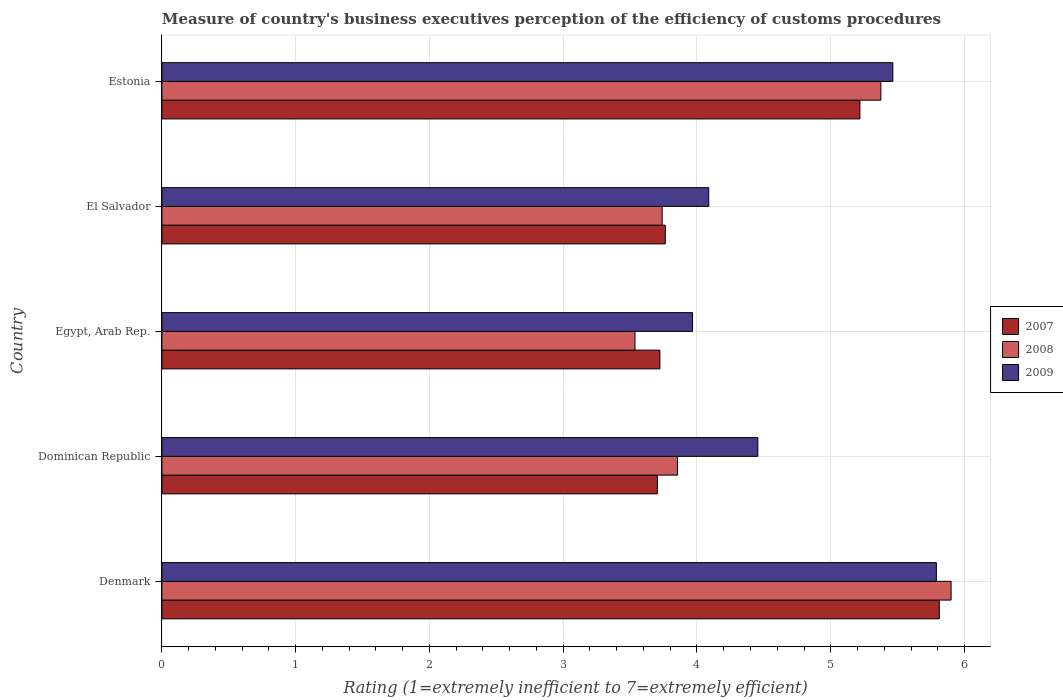How many different coloured bars are there?
Provide a short and direct response. 3. Are the number of bars per tick equal to the number of legend labels?
Provide a short and direct response. Yes. How many bars are there on the 2nd tick from the top?
Provide a succinct answer. 3. How many bars are there on the 5th tick from the bottom?
Offer a terse response. 3. What is the label of the 5th group of bars from the top?
Ensure brevity in your answer.  Denmark. In how many cases, is the number of bars for a given country not equal to the number of legend labels?
Provide a succinct answer. 0. What is the rating of the efficiency of customs procedure in 2009 in Denmark?
Ensure brevity in your answer.  5.79. Across all countries, what is the maximum rating of the efficiency of customs procedure in 2007?
Offer a terse response. 5.81. Across all countries, what is the minimum rating of the efficiency of customs procedure in 2008?
Provide a short and direct response. 3.54. In which country was the rating of the efficiency of customs procedure in 2007 minimum?
Make the answer very short. Dominican Republic. What is the total rating of the efficiency of customs procedure in 2007 in the graph?
Offer a terse response. 22.22. What is the difference between the rating of the efficiency of customs procedure in 2009 in Denmark and that in Dominican Republic?
Provide a succinct answer. 1.33. What is the difference between the rating of the efficiency of customs procedure in 2007 in Denmark and the rating of the efficiency of customs procedure in 2009 in Dominican Republic?
Make the answer very short. 1.36. What is the average rating of the efficiency of customs procedure in 2009 per country?
Your answer should be very brief. 4.75. What is the difference between the rating of the efficiency of customs procedure in 2007 and rating of the efficiency of customs procedure in 2009 in El Salvador?
Offer a terse response. -0.32. What is the ratio of the rating of the efficiency of customs procedure in 2008 in Egypt, Arab Rep. to that in Estonia?
Provide a short and direct response. 0.66. Is the rating of the efficiency of customs procedure in 2008 in Dominican Republic less than that in Egypt, Arab Rep.?
Your response must be concise. No. What is the difference between the highest and the second highest rating of the efficiency of customs procedure in 2008?
Your answer should be compact. 0.52. What is the difference between the highest and the lowest rating of the efficiency of customs procedure in 2009?
Offer a very short reply. 1.82. Is the sum of the rating of the efficiency of customs procedure in 2008 in Egypt, Arab Rep. and Estonia greater than the maximum rating of the efficiency of customs procedure in 2007 across all countries?
Your response must be concise. Yes. Is it the case that in every country, the sum of the rating of the efficiency of customs procedure in 2008 and rating of the efficiency of customs procedure in 2007 is greater than the rating of the efficiency of customs procedure in 2009?
Make the answer very short. Yes. How many bars are there?
Ensure brevity in your answer.  15. Are the values on the major ticks of X-axis written in scientific E-notation?
Make the answer very short. No. Does the graph contain any zero values?
Your answer should be compact. No. Where does the legend appear in the graph?
Your answer should be very brief. Center right. How many legend labels are there?
Provide a short and direct response. 3. What is the title of the graph?
Ensure brevity in your answer.  Measure of country's business executives perception of the efficiency of customs procedures. Does "1960" appear as one of the legend labels in the graph?
Provide a short and direct response. No. What is the label or title of the X-axis?
Keep it short and to the point. Rating (1=extremely inefficient to 7=extremely efficient). What is the Rating (1=extremely inefficient to 7=extremely efficient) in 2007 in Denmark?
Offer a very short reply. 5.81. What is the Rating (1=extremely inefficient to 7=extremely efficient) of 2008 in Denmark?
Provide a short and direct response. 5.9. What is the Rating (1=extremely inefficient to 7=extremely efficient) in 2009 in Denmark?
Offer a very short reply. 5.79. What is the Rating (1=extremely inefficient to 7=extremely efficient) in 2007 in Dominican Republic?
Ensure brevity in your answer.  3.7. What is the Rating (1=extremely inefficient to 7=extremely efficient) of 2008 in Dominican Republic?
Offer a terse response. 3.85. What is the Rating (1=extremely inefficient to 7=extremely efficient) in 2009 in Dominican Republic?
Provide a succinct answer. 4.46. What is the Rating (1=extremely inefficient to 7=extremely efficient) of 2007 in Egypt, Arab Rep.?
Your response must be concise. 3.72. What is the Rating (1=extremely inefficient to 7=extremely efficient) of 2008 in Egypt, Arab Rep.?
Your response must be concise. 3.54. What is the Rating (1=extremely inefficient to 7=extremely efficient) of 2009 in Egypt, Arab Rep.?
Your answer should be very brief. 3.97. What is the Rating (1=extremely inefficient to 7=extremely efficient) in 2007 in El Salvador?
Offer a very short reply. 3.76. What is the Rating (1=extremely inefficient to 7=extremely efficient) of 2008 in El Salvador?
Your answer should be compact. 3.74. What is the Rating (1=extremely inefficient to 7=extremely efficient) in 2009 in El Salvador?
Provide a short and direct response. 4.09. What is the Rating (1=extremely inefficient to 7=extremely efficient) in 2007 in Estonia?
Your answer should be compact. 5.22. What is the Rating (1=extremely inefficient to 7=extremely efficient) in 2008 in Estonia?
Your answer should be very brief. 5.37. What is the Rating (1=extremely inefficient to 7=extremely efficient) in 2009 in Estonia?
Keep it short and to the point. 5.46. Across all countries, what is the maximum Rating (1=extremely inefficient to 7=extremely efficient) of 2007?
Give a very brief answer. 5.81. Across all countries, what is the maximum Rating (1=extremely inefficient to 7=extremely efficient) of 2008?
Keep it short and to the point. 5.9. Across all countries, what is the maximum Rating (1=extremely inefficient to 7=extremely efficient) in 2009?
Give a very brief answer. 5.79. Across all countries, what is the minimum Rating (1=extremely inefficient to 7=extremely efficient) of 2007?
Give a very brief answer. 3.7. Across all countries, what is the minimum Rating (1=extremely inefficient to 7=extremely efficient) of 2008?
Ensure brevity in your answer.  3.54. Across all countries, what is the minimum Rating (1=extremely inefficient to 7=extremely efficient) in 2009?
Give a very brief answer. 3.97. What is the total Rating (1=extremely inefficient to 7=extremely efficient) in 2007 in the graph?
Provide a short and direct response. 22.22. What is the total Rating (1=extremely inefficient to 7=extremely efficient) of 2008 in the graph?
Provide a succinct answer. 22.4. What is the total Rating (1=extremely inefficient to 7=extremely efficient) of 2009 in the graph?
Make the answer very short. 23.76. What is the difference between the Rating (1=extremely inefficient to 7=extremely efficient) of 2007 in Denmark and that in Dominican Republic?
Ensure brevity in your answer.  2.11. What is the difference between the Rating (1=extremely inefficient to 7=extremely efficient) of 2008 in Denmark and that in Dominican Republic?
Offer a terse response. 2.05. What is the difference between the Rating (1=extremely inefficient to 7=extremely efficient) in 2009 in Denmark and that in Dominican Republic?
Give a very brief answer. 1.33. What is the difference between the Rating (1=extremely inefficient to 7=extremely efficient) of 2007 in Denmark and that in Egypt, Arab Rep.?
Provide a short and direct response. 2.09. What is the difference between the Rating (1=extremely inefficient to 7=extremely efficient) of 2008 in Denmark and that in Egypt, Arab Rep.?
Keep it short and to the point. 2.36. What is the difference between the Rating (1=extremely inefficient to 7=extremely efficient) of 2009 in Denmark and that in Egypt, Arab Rep.?
Provide a succinct answer. 1.82. What is the difference between the Rating (1=extremely inefficient to 7=extremely efficient) in 2007 in Denmark and that in El Salvador?
Provide a short and direct response. 2.05. What is the difference between the Rating (1=extremely inefficient to 7=extremely efficient) in 2008 in Denmark and that in El Salvador?
Your answer should be compact. 2.16. What is the difference between the Rating (1=extremely inefficient to 7=extremely efficient) in 2009 in Denmark and that in El Salvador?
Keep it short and to the point. 1.7. What is the difference between the Rating (1=extremely inefficient to 7=extremely efficient) of 2007 in Denmark and that in Estonia?
Provide a short and direct response. 0.59. What is the difference between the Rating (1=extremely inefficient to 7=extremely efficient) in 2008 in Denmark and that in Estonia?
Ensure brevity in your answer.  0.53. What is the difference between the Rating (1=extremely inefficient to 7=extremely efficient) of 2009 in Denmark and that in Estonia?
Your answer should be very brief. 0.33. What is the difference between the Rating (1=extremely inefficient to 7=extremely efficient) in 2007 in Dominican Republic and that in Egypt, Arab Rep.?
Give a very brief answer. -0.02. What is the difference between the Rating (1=extremely inefficient to 7=extremely efficient) in 2008 in Dominican Republic and that in Egypt, Arab Rep.?
Offer a terse response. 0.32. What is the difference between the Rating (1=extremely inefficient to 7=extremely efficient) of 2009 in Dominican Republic and that in Egypt, Arab Rep.?
Give a very brief answer. 0.49. What is the difference between the Rating (1=extremely inefficient to 7=extremely efficient) of 2007 in Dominican Republic and that in El Salvador?
Give a very brief answer. -0.06. What is the difference between the Rating (1=extremely inefficient to 7=extremely efficient) of 2008 in Dominican Republic and that in El Salvador?
Make the answer very short. 0.11. What is the difference between the Rating (1=extremely inefficient to 7=extremely efficient) of 2009 in Dominican Republic and that in El Salvador?
Offer a terse response. 0.37. What is the difference between the Rating (1=extremely inefficient to 7=extremely efficient) of 2007 in Dominican Republic and that in Estonia?
Offer a terse response. -1.51. What is the difference between the Rating (1=extremely inefficient to 7=extremely efficient) of 2008 in Dominican Republic and that in Estonia?
Offer a terse response. -1.52. What is the difference between the Rating (1=extremely inefficient to 7=extremely efficient) of 2009 in Dominican Republic and that in Estonia?
Give a very brief answer. -1.01. What is the difference between the Rating (1=extremely inefficient to 7=extremely efficient) of 2007 in Egypt, Arab Rep. and that in El Salvador?
Offer a very short reply. -0.04. What is the difference between the Rating (1=extremely inefficient to 7=extremely efficient) in 2008 in Egypt, Arab Rep. and that in El Salvador?
Provide a succinct answer. -0.2. What is the difference between the Rating (1=extremely inefficient to 7=extremely efficient) in 2009 in Egypt, Arab Rep. and that in El Salvador?
Give a very brief answer. -0.12. What is the difference between the Rating (1=extremely inefficient to 7=extremely efficient) of 2007 in Egypt, Arab Rep. and that in Estonia?
Provide a short and direct response. -1.5. What is the difference between the Rating (1=extremely inefficient to 7=extremely efficient) in 2008 in Egypt, Arab Rep. and that in Estonia?
Keep it short and to the point. -1.84. What is the difference between the Rating (1=extremely inefficient to 7=extremely efficient) in 2009 in Egypt, Arab Rep. and that in Estonia?
Give a very brief answer. -1.5. What is the difference between the Rating (1=extremely inefficient to 7=extremely efficient) in 2007 in El Salvador and that in Estonia?
Make the answer very short. -1.45. What is the difference between the Rating (1=extremely inefficient to 7=extremely efficient) of 2008 in El Salvador and that in Estonia?
Your answer should be very brief. -1.63. What is the difference between the Rating (1=extremely inefficient to 7=extremely efficient) in 2009 in El Salvador and that in Estonia?
Provide a succinct answer. -1.38. What is the difference between the Rating (1=extremely inefficient to 7=extremely efficient) of 2007 in Denmark and the Rating (1=extremely inefficient to 7=extremely efficient) of 2008 in Dominican Republic?
Provide a succinct answer. 1.96. What is the difference between the Rating (1=extremely inefficient to 7=extremely efficient) of 2007 in Denmark and the Rating (1=extremely inefficient to 7=extremely efficient) of 2009 in Dominican Republic?
Make the answer very short. 1.36. What is the difference between the Rating (1=extremely inefficient to 7=extremely efficient) of 2008 in Denmark and the Rating (1=extremely inefficient to 7=extremely efficient) of 2009 in Dominican Republic?
Provide a short and direct response. 1.44. What is the difference between the Rating (1=extremely inefficient to 7=extremely efficient) in 2007 in Denmark and the Rating (1=extremely inefficient to 7=extremely efficient) in 2008 in Egypt, Arab Rep.?
Your answer should be very brief. 2.28. What is the difference between the Rating (1=extremely inefficient to 7=extremely efficient) in 2007 in Denmark and the Rating (1=extremely inefficient to 7=extremely efficient) in 2009 in Egypt, Arab Rep.?
Provide a short and direct response. 1.84. What is the difference between the Rating (1=extremely inefficient to 7=extremely efficient) of 2008 in Denmark and the Rating (1=extremely inefficient to 7=extremely efficient) of 2009 in Egypt, Arab Rep.?
Your answer should be compact. 1.93. What is the difference between the Rating (1=extremely inefficient to 7=extremely efficient) in 2007 in Denmark and the Rating (1=extremely inefficient to 7=extremely efficient) in 2008 in El Salvador?
Make the answer very short. 2.07. What is the difference between the Rating (1=extremely inefficient to 7=extremely efficient) of 2007 in Denmark and the Rating (1=extremely inefficient to 7=extremely efficient) of 2009 in El Salvador?
Give a very brief answer. 1.72. What is the difference between the Rating (1=extremely inefficient to 7=extremely efficient) in 2008 in Denmark and the Rating (1=extremely inefficient to 7=extremely efficient) in 2009 in El Salvador?
Your answer should be compact. 1.81. What is the difference between the Rating (1=extremely inefficient to 7=extremely efficient) in 2007 in Denmark and the Rating (1=extremely inefficient to 7=extremely efficient) in 2008 in Estonia?
Your answer should be compact. 0.44. What is the difference between the Rating (1=extremely inefficient to 7=extremely efficient) in 2007 in Denmark and the Rating (1=extremely inefficient to 7=extremely efficient) in 2009 in Estonia?
Keep it short and to the point. 0.35. What is the difference between the Rating (1=extremely inefficient to 7=extremely efficient) of 2008 in Denmark and the Rating (1=extremely inefficient to 7=extremely efficient) of 2009 in Estonia?
Ensure brevity in your answer.  0.44. What is the difference between the Rating (1=extremely inefficient to 7=extremely efficient) in 2007 in Dominican Republic and the Rating (1=extremely inefficient to 7=extremely efficient) in 2008 in Egypt, Arab Rep.?
Make the answer very short. 0.17. What is the difference between the Rating (1=extremely inefficient to 7=extremely efficient) of 2007 in Dominican Republic and the Rating (1=extremely inefficient to 7=extremely efficient) of 2009 in Egypt, Arab Rep.?
Your answer should be very brief. -0.26. What is the difference between the Rating (1=extremely inefficient to 7=extremely efficient) of 2008 in Dominican Republic and the Rating (1=extremely inefficient to 7=extremely efficient) of 2009 in Egypt, Arab Rep.?
Give a very brief answer. -0.11. What is the difference between the Rating (1=extremely inefficient to 7=extremely efficient) of 2007 in Dominican Republic and the Rating (1=extremely inefficient to 7=extremely efficient) of 2008 in El Salvador?
Give a very brief answer. -0.04. What is the difference between the Rating (1=extremely inefficient to 7=extremely efficient) of 2007 in Dominican Republic and the Rating (1=extremely inefficient to 7=extremely efficient) of 2009 in El Salvador?
Make the answer very short. -0.38. What is the difference between the Rating (1=extremely inefficient to 7=extremely efficient) of 2008 in Dominican Republic and the Rating (1=extremely inefficient to 7=extremely efficient) of 2009 in El Salvador?
Provide a short and direct response. -0.23. What is the difference between the Rating (1=extremely inefficient to 7=extremely efficient) in 2007 in Dominican Republic and the Rating (1=extremely inefficient to 7=extremely efficient) in 2008 in Estonia?
Offer a terse response. -1.67. What is the difference between the Rating (1=extremely inefficient to 7=extremely efficient) of 2007 in Dominican Republic and the Rating (1=extremely inefficient to 7=extremely efficient) of 2009 in Estonia?
Give a very brief answer. -1.76. What is the difference between the Rating (1=extremely inefficient to 7=extremely efficient) of 2008 in Dominican Republic and the Rating (1=extremely inefficient to 7=extremely efficient) of 2009 in Estonia?
Provide a succinct answer. -1.61. What is the difference between the Rating (1=extremely inefficient to 7=extremely efficient) of 2007 in Egypt, Arab Rep. and the Rating (1=extremely inefficient to 7=extremely efficient) of 2008 in El Salvador?
Provide a short and direct response. -0.02. What is the difference between the Rating (1=extremely inefficient to 7=extremely efficient) of 2007 in Egypt, Arab Rep. and the Rating (1=extremely inefficient to 7=extremely efficient) of 2009 in El Salvador?
Make the answer very short. -0.36. What is the difference between the Rating (1=extremely inefficient to 7=extremely efficient) of 2008 in Egypt, Arab Rep. and the Rating (1=extremely inefficient to 7=extremely efficient) of 2009 in El Salvador?
Provide a short and direct response. -0.55. What is the difference between the Rating (1=extremely inefficient to 7=extremely efficient) of 2007 in Egypt, Arab Rep. and the Rating (1=extremely inefficient to 7=extremely efficient) of 2008 in Estonia?
Make the answer very short. -1.65. What is the difference between the Rating (1=extremely inefficient to 7=extremely efficient) of 2007 in Egypt, Arab Rep. and the Rating (1=extremely inefficient to 7=extremely efficient) of 2009 in Estonia?
Your response must be concise. -1.74. What is the difference between the Rating (1=extremely inefficient to 7=extremely efficient) in 2008 in Egypt, Arab Rep. and the Rating (1=extremely inefficient to 7=extremely efficient) in 2009 in Estonia?
Your response must be concise. -1.93. What is the difference between the Rating (1=extremely inefficient to 7=extremely efficient) in 2007 in El Salvador and the Rating (1=extremely inefficient to 7=extremely efficient) in 2008 in Estonia?
Your answer should be compact. -1.61. What is the difference between the Rating (1=extremely inefficient to 7=extremely efficient) in 2007 in El Salvador and the Rating (1=extremely inefficient to 7=extremely efficient) in 2009 in Estonia?
Provide a short and direct response. -1.7. What is the difference between the Rating (1=extremely inefficient to 7=extremely efficient) of 2008 in El Salvador and the Rating (1=extremely inefficient to 7=extremely efficient) of 2009 in Estonia?
Give a very brief answer. -1.72. What is the average Rating (1=extremely inefficient to 7=extremely efficient) in 2007 per country?
Make the answer very short. 4.44. What is the average Rating (1=extremely inefficient to 7=extremely efficient) of 2008 per country?
Keep it short and to the point. 4.48. What is the average Rating (1=extremely inefficient to 7=extremely efficient) of 2009 per country?
Offer a terse response. 4.75. What is the difference between the Rating (1=extremely inefficient to 7=extremely efficient) in 2007 and Rating (1=extremely inefficient to 7=extremely efficient) in 2008 in Denmark?
Make the answer very short. -0.09. What is the difference between the Rating (1=extremely inefficient to 7=extremely efficient) of 2007 and Rating (1=extremely inefficient to 7=extremely efficient) of 2009 in Denmark?
Make the answer very short. 0.02. What is the difference between the Rating (1=extremely inefficient to 7=extremely efficient) in 2008 and Rating (1=extremely inefficient to 7=extremely efficient) in 2009 in Denmark?
Make the answer very short. 0.11. What is the difference between the Rating (1=extremely inefficient to 7=extremely efficient) of 2007 and Rating (1=extremely inefficient to 7=extremely efficient) of 2008 in Dominican Republic?
Your answer should be compact. -0.15. What is the difference between the Rating (1=extremely inefficient to 7=extremely efficient) in 2007 and Rating (1=extremely inefficient to 7=extremely efficient) in 2009 in Dominican Republic?
Make the answer very short. -0.75. What is the difference between the Rating (1=extremely inefficient to 7=extremely efficient) of 2008 and Rating (1=extremely inefficient to 7=extremely efficient) of 2009 in Dominican Republic?
Give a very brief answer. -0.6. What is the difference between the Rating (1=extremely inefficient to 7=extremely efficient) of 2007 and Rating (1=extremely inefficient to 7=extremely efficient) of 2008 in Egypt, Arab Rep.?
Keep it short and to the point. 0.19. What is the difference between the Rating (1=extremely inefficient to 7=extremely efficient) of 2007 and Rating (1=extremely inefficient to 7=extremely efficient) of 2009 in Egypt, Arab Rep.?
Offer a very short reply. -0.24. What is the difference between the Rating (1=extremely inefficient to 7=extremely efficient) in 2008 and Rating (1=extremely inefficient to 7=extremely efficient) in 2009 in Egypt, Arab Rep.?
Make the answer very short. -0.43. What is the difference between the Rating (1=extremely inefficient to 7=extremely efficient) of 2007 and Rating (1=extremely inefficient to 7=extremely efficient) of 2008 in El Salvador?
Offer a terse response. 0.02. What is the difference between the Rating (1=extremely inefficient to 7=extremely efficient) in 2007 and Rating (1=extremely inefficient to 7=extremely efficient) in 2009 in El Salvador?
Your answer should be compact. -0.32. What is the difference between the Rating (1=extremely inefficient to 7=extremely efficient) of 2008 and Rating (1=extremely inefficient to 7=extremely efficient) of 2009 in El Salvador?
Provide a succinct answer. -0.35. What is the difference between the Rating (1=extremely inefficient to 7=extremely efficient) in 2007 and Rating (1=extremely inefficient to 7=extremely efficient) in 2008 in Estonia?
Provide a short and direct response. -0.16. What is the difference between the Rating (1=extremely inefficient to 7=extremely efficient) of 2007 and Rating (1=extremely inefficient to 7=extremely efficient) of 2009 in Estonia?
Ensure brevity in your answer.  -0.25. What is the difference between the Rating (1=extremely inefficient to 7=extremely efficient) of 2008 and Rating (1=extremely inefficient to 7=extremely efficient) of 2009 in Estonia?
Your response must be concise. -0.09. What is the ratio of the Rating (1=extremely inefficient to 7=extremely efficient) in 2007 in Denmark to that in Dominican Republic?
Offer a terse response. 1.57. What is the ratio of the Rating (1=extremely inefficient to 7=extremely efficient) in 2008 in Denmark to that in Dominican Republic?
Your answer should be very brief. 1.53. What is the ratio of the Rating (1=extremely inefficient to 7=extremely efficient) in 2009 in Denmark to that in Dominican Republic?
Provide a short and direct response. 1.3. What is the ratio of the Rating (1=extremely inefficient to 7=extremely efficient) of 2007 in Denmark to that in Egypt, Arab Rep.?
Offer a very short reply. 1.56. What is the ratio of the Rating (1=extremely inefficient to 7=extremely efficient) of 2008 in Denmark to that in Egypt, Arab Rep.?
Your response must be concise. 1.67. What is the ratio of the Rating (1=extremely inefficient to 7=extremely efficient) in 2009 in Denmark to that in Egypt, Arab Rep.?
Give a very brief answer. 1.46. What is the ratio of the Rating (1=extremely inefficient to 7=extremely efficient) in 2007 in Denmark to that in El Salvador?
Your answer should be compact. 1.54. What is the ratio of the Rating (1=extremely inefficient to 7=extremely efficient) in 2008 in Denmark to that in El Salvador?
Give a very brief answer. 1.58. What is the ratio of the Rating (1=extremely inefficient to 7=extremely efficient) of 2009 in Denmark to that in El Salvador?
Your answer should be compact. 1.42. What is the ratio of the Rating (1=extremely inefficient to 7=extremely efficient) of 2007 in Denmark to that in Estonia?
Give a very brief answer. 1.11. What is the ratio of the Rating (1=extremely inefficient to 7=extremely efficient) in 2008 in Denmark to that in Estonia?
Ensure brevity in your answer.  1.1. What is the ratio of the Rating (1=extremely inefficient to 7=extremely efficient) of 2009 in Denmark to that in Estonia?
Offer a very short reply. 1.06. What is the ratio of the Rating (1=extremely inefficient to 7=extremely efficient) in 2007 in Dominican Republic to that in Egypt, Arab Rep.?
Ensure brevity in your answer.  0.99. What is the ratio of the Rating (1=extremely inefficient to 7=extremely efficient) of 2008 in Dominican Republic to that in Egypt, Arab Rep.?
Offer a very short reply. 1.09. What is the ratio of the Rating (1=extremely inefficient to 7=extremely efficient) in 2009 in Dominican Republic to that in Egypt, Arab Rep.?
Keep it short and to the point. 1.12. What is the ratio of the Rating (1=extremely inefficient to 7=extremely efficient) of 2007 in Dominican Republic to that in El Salvador?
Offer a terse response. 0.98. What is the ratio of the Rating (1=extremely inefficient to 7=extremely efficient) in 2008 in Dominican Republic to that in El Salvador?
Make the answer very short. 1.03. What is the ratio of the Rating (1=extremely inefficient to 7=extremely efficient) of 2009 in Dominican Republic to that in El Salvador?
Offer a very short reply. 1.09. What is the ratio of the Rating (1=extremely inefficient to 7=extremely efficient) in 2007 in Dominican Republic to that in Estonia?
Your answer should be very brief. 0.71. What is the ratio of the Rating (1=extremely inefficient to 7=extremely efficient) of 2008 in Dominican Republic to that in Estonia?
Make the answer very short. 0.72. What is the ratio of the Rating (1=extremely inefficient to 7=extremely efficient) in 2009 in Dominican Republic to that in Estonia?
Give a very brief answer. 0.82. What is the ratio of the Rating (1=extremely inefficient to 7=extremely efficient) in 2007 in Egypt, Arab Rep. to that in El Salvador?
Make the answer very short. 0.99. What is the ratio of the Rating (1=extremely inefficient to 7=extremely efficient) of 2008 in Egypt, Arab Rep. to that in El Salvador?
Ensure brevity in your answer.  0.95. What is the ratio of the Rating (1=extremely inefficient to 7=extremely efficient) in 2009 in Egypt, Arab Rep. to that in El Salvador?
Your answer should be compact. 0.97. What is the ratio of the Rating (1=extremely inefficient to 7=extremely efficient) of 2007 in Egypt, Arab Rep. to that in Estonia?
Your response must be concise. 0.71. What is the ratio of the Rating (1=extremely inefficient to 7=extremely efficient) in 2008 in Egypt, Arab Rep. to that in Estonia?
Your answer should be compact. 0.66. What is the ratio of the Rating (1=extremely inefficient to 7=extremely efficient) of 2009 in Egypt, Arab Rep. to that in Estonia?
Ensure brevity in your answer.  0.73. What is the ratio of the Rating (1=extremely inefficient to 7=extremely efficient) of 2007 in El Salvador to that in Estonia?
Keep it short and to the point. 0.72. What is the ratio of the Rating (1=extremely inefficient to 7=extremely efficient) of 2008 in El Salvador to that in Estonia?
Keep it short and to the point. 0.7. What is the ratio of the Rating (1=extremely inefficient to 7=extremely efficient) of 2009 in El Salvador to that in Estonia?
Your response must be concise. 0.75. What is the difference between the highest and the second highest Rating (1=extremely inefficient to 7=extremely efficient) in 2007?
Make the answer very short. 0.59. What is the difference between the highest and the second highest Rating (1=extremely inefficient to 7=extremely efficient) in 2008?
Your answer should be very brief. 0.53. What is the difference between the highest and the second highest Rating (1=extremely inefficient to 7=extremely efficient) in 2009?
Your response must be concise. 0.33. What is the difference between the highest and the lowest Rating (1=extremely inefficient to 7=extremely efficient) in 2007?
Make the answer very short. 2.11. What is the difference between the highest and the lowest Rating (1=extremely inefficient to 7=extremely efficient) of 2008?
Provide a succinct answer. 2.36. What is the difference between the highest and the lowest Rating (1=extremely inefficient to 7=extremely efficient) of 2009?
Ensure brevity in your answer.  1.82. 